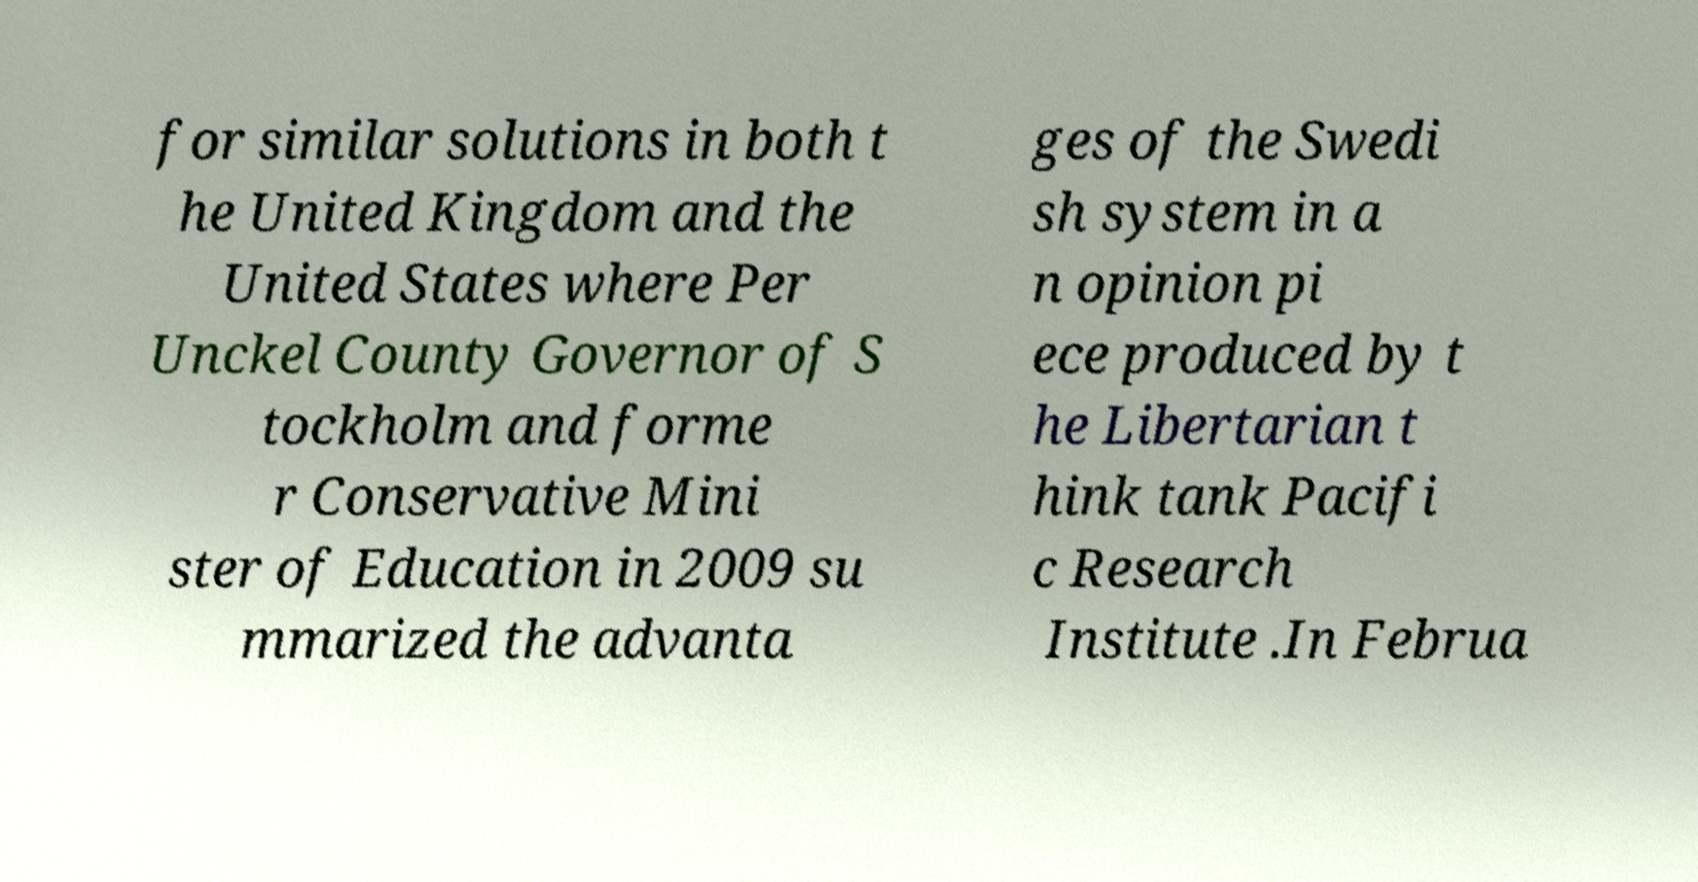I need the written content from this picture converted into text. Can you do that? for similar solutions in both t he United Kingdom and the United States where Per Unckel County Governor of S tockholm and forme r Conservative Mini ster of Education in 2009 su mmarized the advanta ges of the Swedi sh system in a n opinion pi ece produced by t he Libertarian t hink tank Pacifi c Research Institute .In Februa 